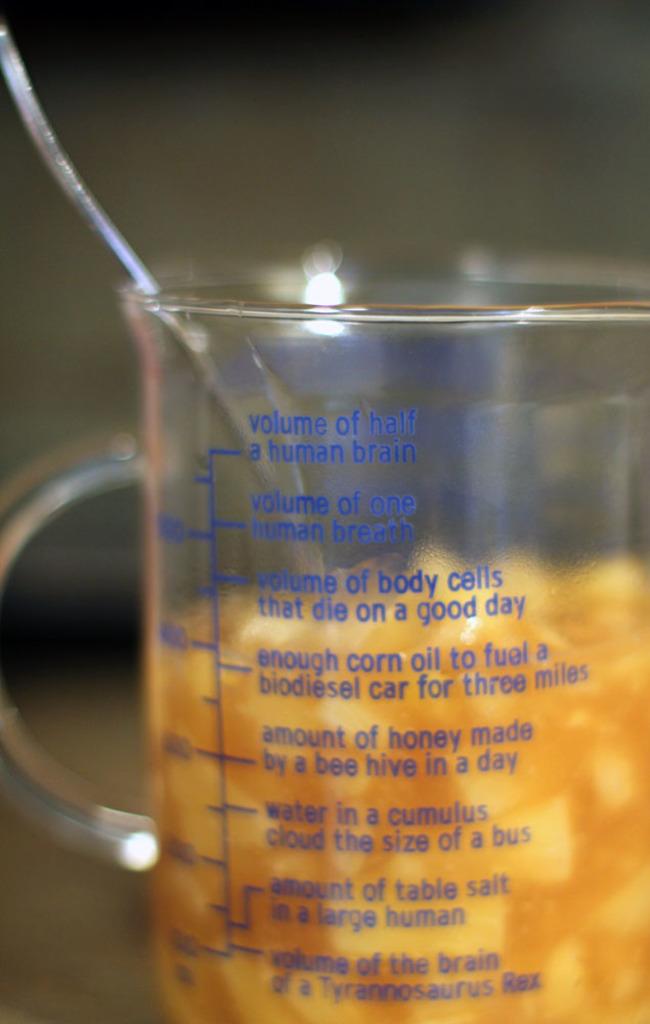How much can this container hold?
Provide a short and direct response. Volume of half a human brain. 